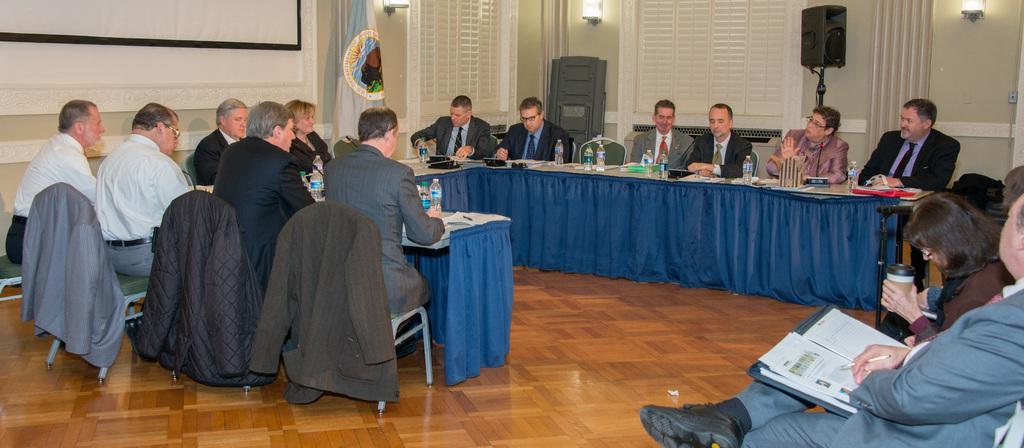How would you summarize this image in a sentence or two? This image is taken in a hall where on the right, there is a man sitting and holding a pen and a file. There is a woman sitting and holding a container. In the middle, there are persons sitting on the chairs near the table on which papers, files, bottles and a pen on it. On the left side of the image, there are three coats on the chairs. In the background, there is a screen, wall, flag, few lights, windows, a black object and a speaker box. 